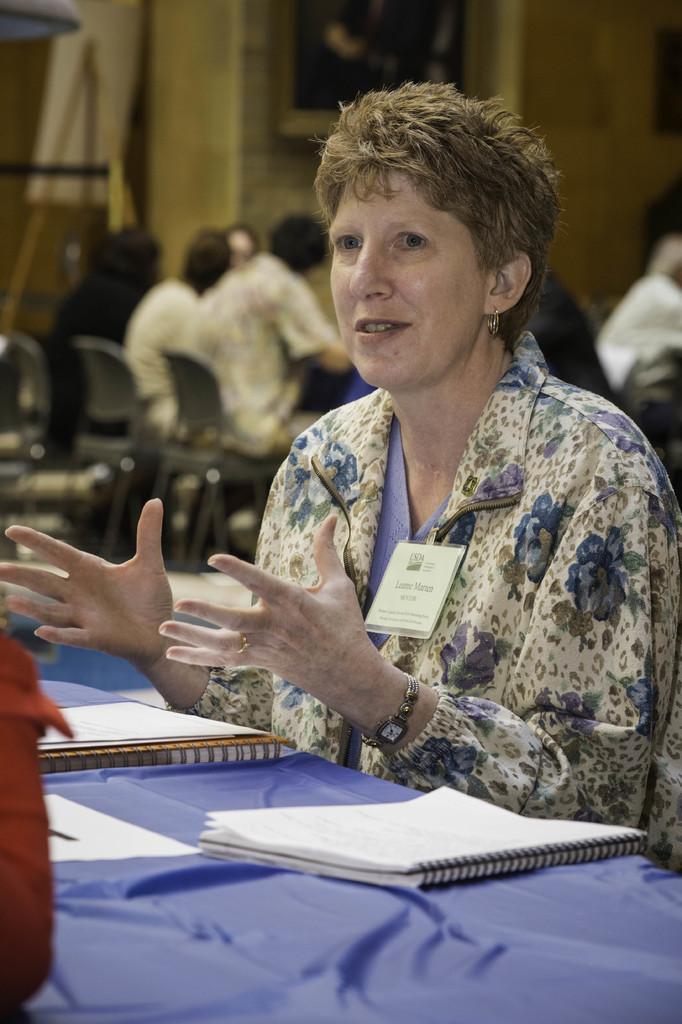Can you describe this image briefly? A lady wearing a floral dress, tag and a watch is also speaking. In front of her there is a table with blue sheet. On the table there are books. In the background there are some people, wall. 